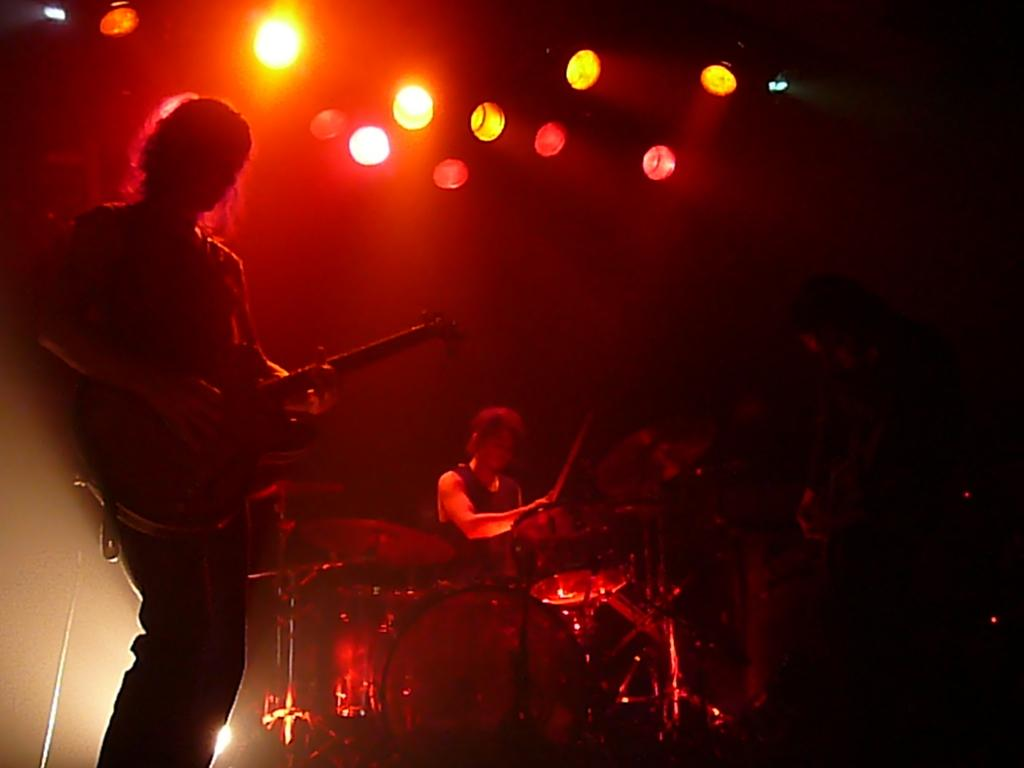Who or what can be seen in the image? There are people in the image. What are the people doing in the image? Musical instruments are present in the image, and a man is holding a guitar with his hands. What can be seen illuminating the scene in the image? Lights are visible in the image. How would you describe the overall lighting in the image? The background of the image is dark. How much does the sack weigh in the image? There is no sack present in the image, so it is not possible to determine its weight. 